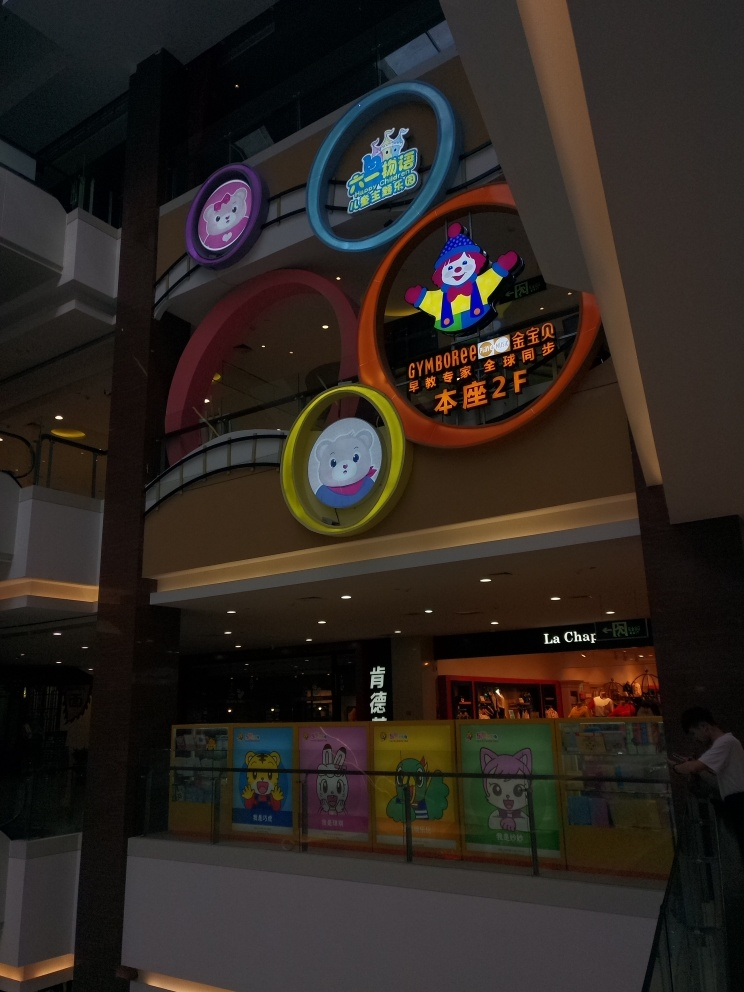Can you describe the ambience or the atmosphere that this picture seems to depict? The atmosphere conveyed by the picture appears to be cheerful and inviting, primarily due to the colorful signage and character designs that likely appeal to children. However, the lighting is subdued, suggesting that the photo might have been taken during the evening or in a relatively dim indoor space, which adds a calm and less hectic feel to the ambience of the shopping area. 